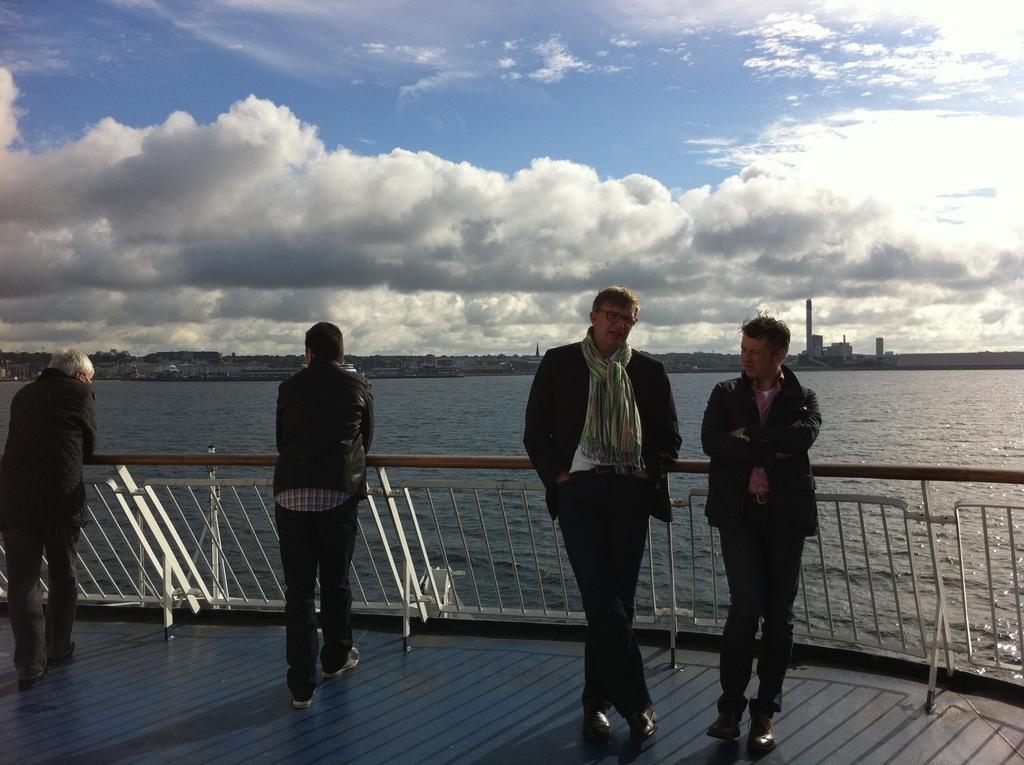Could you give a brief overview of what you see in this image? In the image four persons are standing. Behind them there is fencing. Behind the fencing there is water. Behind the water there are some buildings. At the top of the image there are some clouds in the sky. 